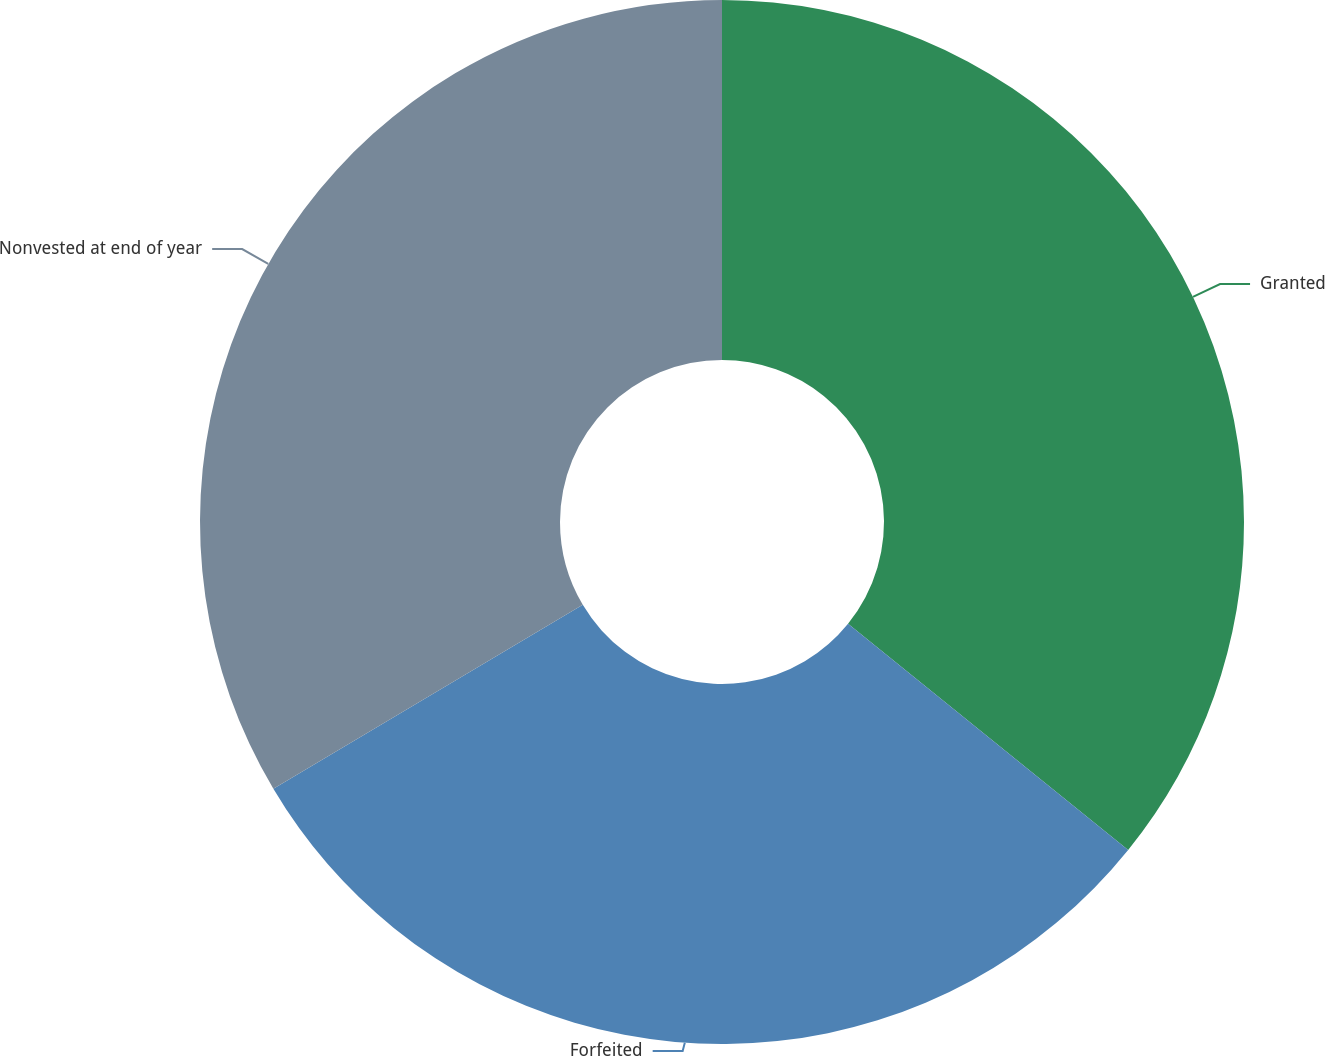Convert chart. <chart><loc_0><loc_0><loc_500><loc_500><pie_chart><fcel>Granted<fcel>Forfeited<fcel>Nonvested at end of year<nl><fcel>35.81%<fcel>30.65%<fcel>33.54%<nl></chart> 